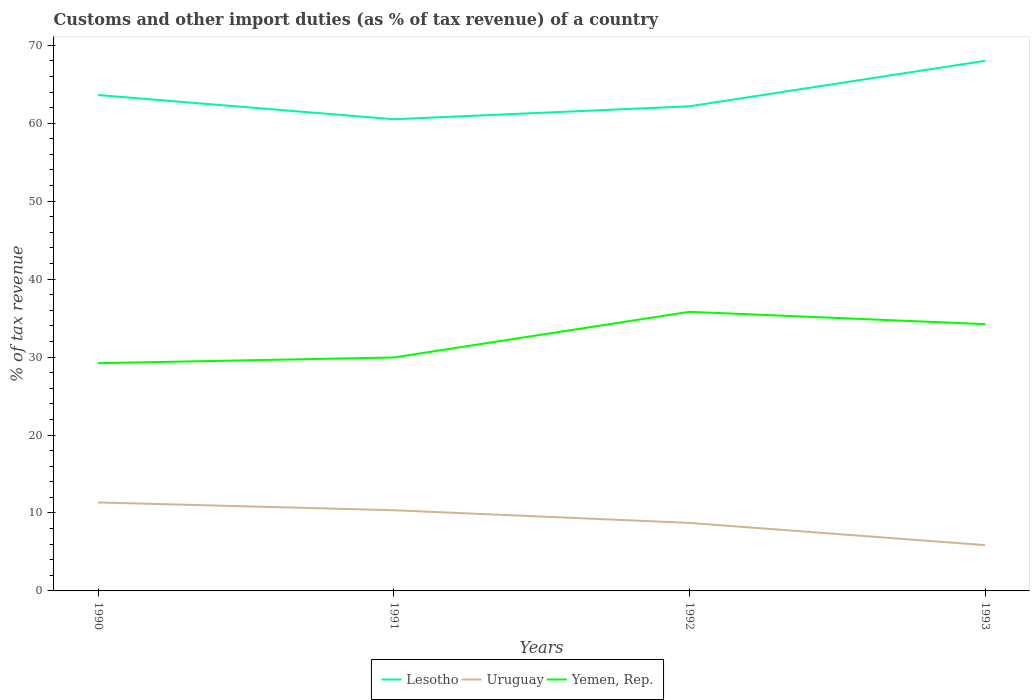Does the line corresponding to Yemen, Rep. intersect with the line corresponding to Uruguay?
Make the answer very short. No. Is the number of lines equal to the number of legend labels?
Make the answer very short. Yes. Across all years, what is the maximum percentage of tax revenue from customs in Lesotho?
Make the answer very short. 60.51. In which year was the percentage of tax revenue from customs in Uruguay maximum?
Give a very brief answer. 1993. What is the total percentage of tax revenue from customs in Yemen, Rep. in the graph?
Provide a short and direct response. -0.74. What is the difference between the highest and the second highest percentage of tax revenue from customs in Lesotho?
Your answer should be very brief. 7.5. Are the values on the major ticks of Y-axis written in scientific E-notation?
Provide a short and direct response. No. Does the graph contain grids?
Offer a very short reply. No. Where does the legend appear in the graph?
Your answer should be very brief. Bottom center. What is the title of the graph?
Keep it short and to the point. Customs and other import duties (as % of tax revenue) of a country. What is the label or title of the X-axis?
Your answer should be very brief. Years. What is the label or title of the Y-axis?
Make the answer very short. % of tax revenue. What is the % of tax revenue of Lesotho in 1990?
Your response must be concise. 63.62. What is the % of tax revenue of Uruguay in 1990?
Your response must be concise. 11.35. What is the % of tax revenue of Yemen, Rep. in 1990?
Provide a succinct answer. 29.21. What is the % of tax revenue of Lesotho in 1991?
Offer a terse response. 60.51. What is the % of tax revenue in Uruguay in 1991?
Offer a very short reply. 10.35. What is the % of tax revenue of Yemen, Rep. in 1991?
Offer a terse response. 29.95. What is the % of tax revenue in Lesotho in 1992?
Give a very brief answer. 62.17. What is the % of tax revenue in Uruguay in 1992?
Your answer should be very brief. 8.73. What is the % of tax revenue of Yemen, Rep. in 1992?
Offer a very short reply. 35.81. What is the % of tax revenue of Lesotho in 1993?
Your response must be concise. 68.01. What is the % of tax revenue in Uruguay in 1993?
Your answer should be compact. 5.87. What is the % of tax revenue of Yemen, Rep. in 1993?
Give a very brief answer. 34.22. Across all years, what is the maximum % of tax revenue of Lesotho?
Your answer should be very brief. 68.01. Across all years, what is the maximum % of tax revenue in Uruguay?
Make the answer very short. 11.35. Across all years, what is the maximum % of tax revenue of Yemen, Rep.?
Keep it short and to the point. 35.81. Across all years, what is the minimum % of tax revenue of Lesotho?
Your response must be concise. 60.51. Across all years, what is the minimum % of tax revenue in Uruguay?
Provide a short and direct response. 5.87. Across all years, what is the minimum % of tax revenue in Yemen, Rep.?
Give a very brief answer. 29.21. What is the total % of tax revenue in Lesotho in the graph?
Offer a very short reply. 254.31. What is the total % of tax revenue of Uruguay in the graph?
Offer a very short reply. 36.3. What is the total % of tax revenue in Yemen, Rep. in the graph?
Give a very brief answer. 129.19. What is the difference between the % of tax revenue in Lesotho in 1990 and that in 1991?
Keep it short and to the point. 3.11. What is the difference between the % of tax revenue of Uruguay in 1990 and that in 1991?
Ensure brevity in your answer.  1. What is the difference between the % of tax revenue of Yemen, Rep. in 1990 and that in 1991?
Your answer should be very brief. -0.74. What is the difference between the % of tax revenue of Lesotho in 1990 and that in 1992?
Ensure brevity in your answer.  1.44. What is the difference between the % of tax revenue in Uruguay in 1990 and that in 1992?
Your response must be concise. 2.63. What is the difference between the % of tax revenue in Yemen, Rep. in 1990 and that in 1992?
Offer a terse response. -6.59. What is the difference between the % of tax revenue in Lesotho in 1990 and that in 1993?
Offer a terse response. -4.39. What is the difference between the % of tax revenue in Uruguay in 1990 and that in 1993?
Give a very brief answer. 5.48. What is the difference between the % of tax revenue of Yemen, Rep. in 1990 and that in 1993?
Keep it short and to the point. -5.01. What is the difference between the % of tax revenue in Lesotho in 1991 and that in 1992?
Offer a very short reply. -1.66. What is the difference between the % of tax revenue of Uruguay in 1991 and that in 1992?
Provide a succinct answer. 1.62. What is the difference between the % of tax revenue in Yemen, Rep. in 1991 and that in 1992?
Provide a short and direct response. -5.86. What is the difference between the % of tax revenue in Lesotho in 1991 and that in 1993?
Your answer should be compact. -7.5. What is the difference between the % of tax revenue of Uruguay in 1991 and that in 1993?
Ensure brevity in your answer.  4.48. What is the difference between the % of tax revenue in Yemen, Rep. in 1991 and that in 1993?
Offer a terse response. -4.27. What is the difference between the % of tax revenue of Lesotho in 1992 and that in 1993?
Keep it short and to the point. -5.84. What is the difference between the % of tax revenue in Uruguay in 1992 and that in 1993?
Provide a short and direct response. 2.85. What is the difference between the % of tax revenue in Yemen, Rep. in 1992 and that in 1993?
Offer a terse response. 1.58. What is the difference between the % of tax revenue of Lesotho in 1990 and the % of tax revenue of Uruguay in 1991?
Your answer should be compact. 53.27. What is the difference between the % of tax revenue of Lesotho in 1990 and the % of tax revenue of Yemen, Rep. in 1991?
Provide a succinct answer. 33.67. What is the difference between the % of tax revenue in Uruguay in 1990 and the % of tax revenue in Yemen, Rep. in 1991?
Ensure brevity in your answer.  -18.6. What is the difference between the % of tax revenue of Lesotho in 1990 and the % of tax revenue of Uruguay in 1992?
Give a very brief answer. 54.89. What is the difference between the % of tax revenue of Lesotho in 1990 and the % of tax revenue of Yemen, Rep. in 1992?
Ensure brevity in your answer.  27.81. What is the difference between the % of tax revenue in Uruguay in 1990 and the % of tax revenue in Yemen, Rep. in 1992?
Make the answer very short. -24.46. What is the difference between the % of tax revenue of Lesotho in 1990 and the % of tax revenue of Uruguay in 1993?
Your answer should be compact. 57.75. What is the difference between the % of tax revenue in Lesotho in 1990 and the % of tax revenue in Yemen, Rep. in 1993?
Provide a short and direct response. 29.39. What is the difference between the % of tax revenue in Uruguay in 1990 and the % of tax revenue in Yemen, Rep. in 1993?
Provide a short and direct response. -22.87. What is the difference between the % of tax revenue in Lesotho in 1991 and the % of tax revenue in Uruguay in 1992?
Offer a terse response. 51.78. What is the difference between the % of tax revenue of Lesotho in 1991 and the % of tax revenue of Yemen, Rep. in 1992?
Provide a succinct answer. 24.7. What is the difference between the % of tax revenue of Uruguay in 1991 and the % of tax revenue of Yemen, Rep. in 1992?
Ensure brevity in your answer.  -25.46. What is the difference between the % of tax revenue in Lesotho in 1991 and the % of tax revenue in Uruguay in 1993?
Offer a very short reply. 54.64. What is the difference between the % of tax revenue of Lesotho in 1991 and the % of tax revenue of Yemen, Rep. in 1993?
Your response must be concise. 26.29. What is the difference between the % of tax revenue of Uruguay in 1991 and the % of tax revenue of Yemen, Rep. in 1993?
Your answer should be compact. -23.87. What is the difference between the % of tax revenue of Lesotho in 1992 and the % of tax revenue of Uruguay in 1993?
Give a very brief answer. 56.3. What is the difference between the % of tax revenue in Lesotho in 1992 and the % of tax revenue in Yemen, Rep. in 1993?
Your response must be concise. 27.95. What is the difference between the % of tax revenue of Uruguay in 1992 and the % of tax revenue of Yemen, Rep. in 1993?
Offer a terse response. -25.5. What is the average % of tax revenue of Lesotho per year?
Keep it short and to the point. 63.58. What is the average % of tax revenue in Uruguay per year?
Give a very brief answer. 9.07. What is the average % of tax revenue in Yemen, Rep. per year?
Offer a terse response. 32.3. In the year 1990, what is the difference between the % of tax revenue in Lesotho and % of tax revenue in Uruguay?
Offer a very short reply. 52.27. In the year 1990, what is the difference between the % of tax revenue of Lesotho and % of tax revenue of Yemen, Rep.?
Your answer should be very brief. 34.4. In the year 1990, what is the difference between the % of tax revenue in Uruguay and % of tax revenue in Yemen, Rep.?
Keep it short and to the point. -17.86. In the year 1991, what is the difference between the % of tax revenue of Lesotho and % of tax revenue of Uruguay?
Keep it short and to the point. 50.16. In the year 1991, what is the difference between the % of tax revenue in Lesotho and % of tax revenue in Yemen, Rep.?
Provide a short and direct response. 30.56. In the year 1991, what is the difference between the % of tax revenue of Uruguay and % of tax revenue of Yemen, Rep.?
Offer a very short reply. -19.6. In the year 1992, what is the difference between the % of tax revenue in Lesotho and % of tax revenue in Uruguay?
Provide a succinct answer. 53.45. In the year 1992, what is the difference between the % of tax revenue of Lesotho and % of tax revenue of Yemen, Rep.?
Keep it short and to the point. 26.37. In the year 1992, what is the difference between the % of tax revenue in Uruguay and % of tax revenue in Yemen, Rep.?
Your response must be concise. -27.08. In the year 1993, what is the difference between the % of tax revenue of Lesotho and % of tax revenue of Uruguay?
Ensure brevity in your answer.  62.14. In the year 1993, what is the difference between the % of tax revenue in Lesotho and % of tax revenue in Yemen, Rep.?
Ensure brevity in your answer.  33.78. In the year 1993, what is the difference between the % of tax revenue of Uruguay and % of tax revenue of Yemen, Rep.?
Ensure brevity in your answer.  -28.35. What is the ratio of the % of tax revenue of Lesotho in 1990 to that in 1991?
Make the answer very short. 1.05. What is the ratio of the % of tax revenue in Uruguay in 1990 to that in 1991?
Your answer should be very brief. 1.1. What is the ratio of the % of tax revenue in Yemen, Rep. in 1990 to that in 1991?
Offer a very short reply. 0.98. What is the ratio of the % of tax revenue in Lesotho in 1990 to that in 1992?
Offer a terse response. 1.02. What is the ratio of the % of tax revenue in Uruguay in 1990 to that in 1992?
Offer a very short reply. 1.3. What is the ratio of the % of tax revenue of Yemen, Rep. in 1990 to that in 1992?
Provide a succinct answer. 0.82. What is the ratio of the % of tax revenue in Lesotho in 1990 to that in 1993?
Give a very brief answer. 0.94. What is the ratio of the % of tax revenue in Uruguay in 1990 to that in 1993?
Give a very brief answer. 1.93. What is the ratio of the % of tax revenue in Yemen, Rep. in 1990 to that in 1993?
Give a very brief answer. 0.85. What is the ratio of the % of tax revenue in Lesotho in 1991 to that in 1992?
Your answer should be very brief. 0.97. What is the ratio of the % of tax revenue in Uruguay in 1991 to that in 1992?
Your response must be concise. 1.19. What is the ratio of the % of tax revenue in Yemen, Rep. in 1991 to that in 1992?
Provide a short and direct response. 0.84. What is the ratio of the % of tax revenue in Lesotho in 1991 to that in 1993?
Provide a succinct answer. 0.89. What is the ratio of the % of tax revenue of Uruguay in 1991 to that in 1993?
Ensure brevity in your answer.  1.76. What is the ratio of the % of tax revenue of Yemen, Rep. in 1991 to that in 1993?
Make the answer very short. 0.88. What is the ratio of the % of tax revenue of Lesotho in 1992 to that in 1993?
Your answer should be compact. 0.91. What is the ratio of the % of tax revenue in Uruguay in 1992 to that in 1993?
Ensure brevity in your answer.  1.49. What is the ratio of the % of tax revenue of Yemen, Rep. in 1992 to that in 1993?
Your response must be concise. 1.05. What is the difference between the highest and the second highest % of tax revenue in Lesotho?
Offer a very short reply. 4.39. What is the difference between the highest and the second highest % of tax revenue in Yemen, Rep.?
Your answer should be very brief. 1.58. What is the difference between the highest and the lowest % of tax revenue of Lesotho?
Offer a terse response. 7.5. What is the difference between the highest and the lowest % of tax revenue of Uruguay?
Your response must be concise. 5.48. What is the difference between the highest and the lowest % of tax revenue in Yemen, Rep.?
Ensure brevity in your answer.  6.59. 